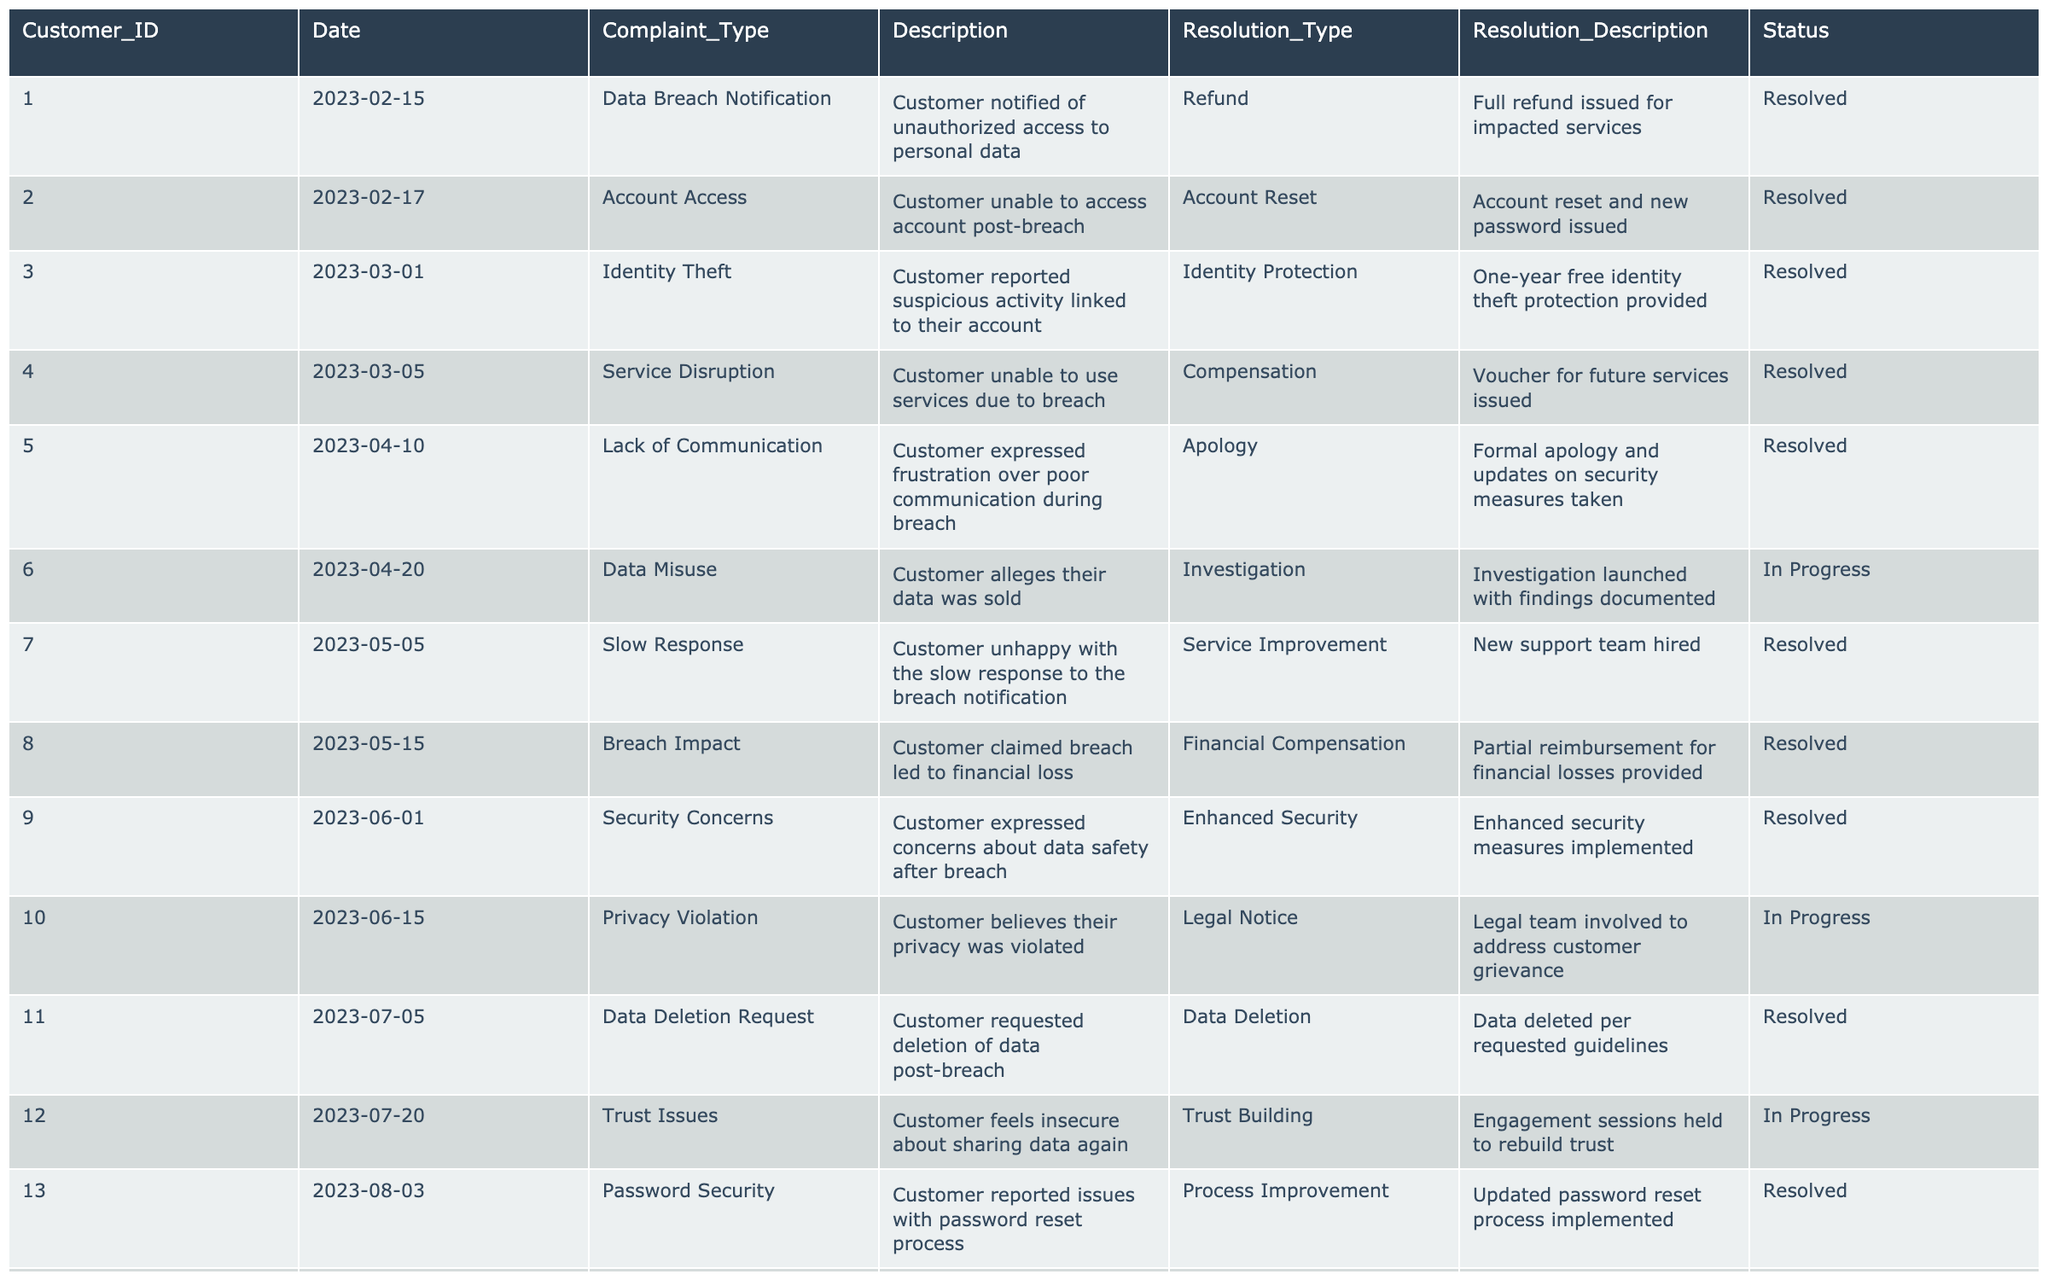What is the total number of customer complaints resolved? There are 20 rows in the table. By reviewing the 'Status' column, we see that 15 complaints have a status of 'Resolved' and 5 are in progress. Thus, the total number of resolved complaints is 15.
Answer: 15 How many customers reported identity theft? Looking at the 'Complaint_Type' column, there is only one entry related to identity theft (Customer_ID 003). Hence, the total number of customers reporting identity theft is one.
Answer: 1 What resolution type was most frequently provided to customers? By examining the 'Resolution_Type' column, we can count the types of resolutions given. Notably, 'Refund' appears 3 times, while other types like 'Compensation' and 'Investigation' appear less frequently. Therefore, 'Refund' is the most common resolution.
Answer: Refund Did any customer express a lack of communication during the breach? By scanning the 'Description' column, we find that Customer_ID 005 explicitly mentioned frustration over poor communication during the breach. This indicates that at least one customer did indeed express this concern.
Answer: Yes What percentage of complaints were related to issues of security? We identify that 'Security Concerns', 'Privacy Violation', and 'Phishing Attempts' all relate to security issues. Counting these complaints gives us 3 out of 20. To find the percentage, we calculate (3/20) * 100, which equals 15%.
Answer: 15% Which complaint type had the slowest resolution response? To determine this, we can compare the time gaps between the complaint date and resolution date where possible. For example, we see that 'Account Access' (Customer_ID 002) was resolved quickly. However, 'Data Misuse' (Customer_ID 006) is still 'In Progress' and has not seen resolution. Therefore, this situation represents the slowest resolution response.
Answer: Data Misuse How many resolutions are still in progress? By examining the 'Status' column, we see that there are 5 entries marked as 'In Progress'. This gives us the answer we are looking for.
Answer: 5 Which customer's complaint related to trust issues and what was the resolution? By searching through the 'Trust Issues' row (Customer_ID 012), we find that the resolution involved holding engagement sessions to rebuild trust.
Answer: Customer 012, resolution: Trust Building How many different types of complaints were recorded? To find the count of different complaint types, we can check the 'Complaint_Type' column for unique entries. There are 12 distinct types of complaints listed.
Answer: 12 What was the most common resolution description provided? Looking through the 'Resolution_Description' column, the detailed descriptions indicate that the resolutions varied, although many involved refunds, investigations, or enhanced security measures. However, 'Full refund issued for impacted services' and its variants appear multiple times.
Answer: Full refund issued for impacted services 